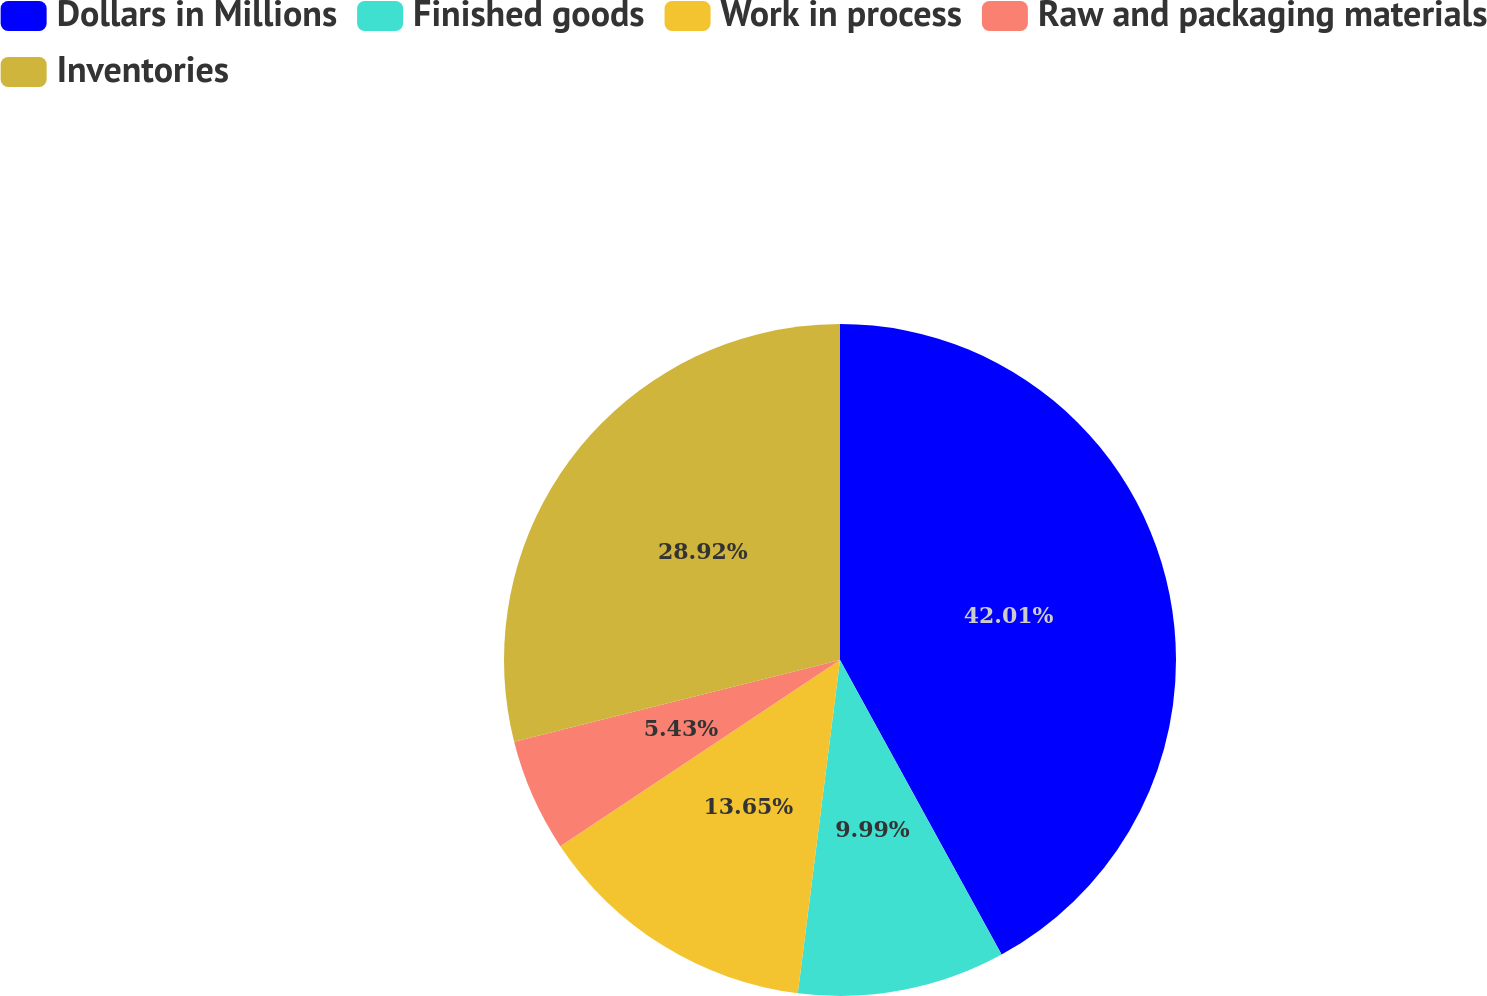Convert chart to OTSL. <chart><loc_0><loc_0><loc_500><loc_500><pie_chart><fcel>Dollars in Millions<fcel>Finished goods<fcel>Work in process<fcel>Raw and packaging materials<fcel>Inventories<nl><fcel>42.02%<fcel>9.99%<fcel>13.65%<fcel>5.43%<fcel>28.92%<nl></chart> 